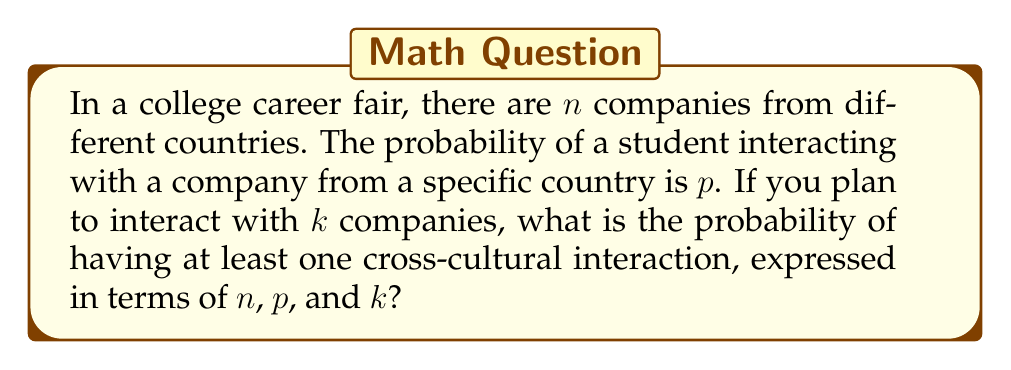Can you answer this question? Let's approach this step-by-step:

1) First, let's consider the probability of not having a cross-cultural interaction with a single company. This would be $(1-p)$.

2) For $k$ interactions, the probability of not having any cross-cultural interactions would be $(1-p)^k$.

3) Therefore, the probability of having at least one cross-cultural interaction is the complement of having no cross-cultural interactions:

   $$P(\text{at least one cross-cultural interaction}) = 1 - P(\text{no cross-cultural interactions})$$

4) We can express this as:

   $$P(\text{at least one cross-cultural interaction}) = 1 - (1-p)^k$$

5) This expression gives us the probability in terms of $p$ and $k$, as required.

6) Note that $n$ doesn't appear in the final expression because the number of companies doesn't affect the probability once we know $p$ and $k$. However, $n$ could be used to calculate $p$ if additional information were given.
Answer: $1 - (1-p)^k$ 